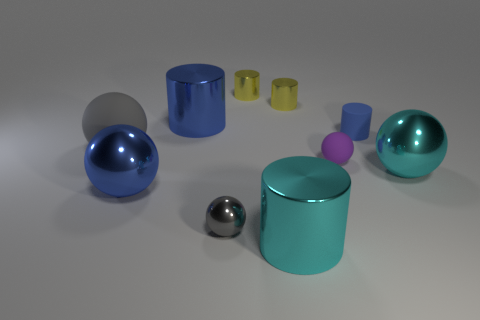The large cylinder that is to the left of the cylinder in front of the large rubber ball is what color?
Give a very brief answer. Blue. What material is the big object that is the same color as the small metal sphere?
Your answer should be compact. Rubber. There is a tiny cylinder that is to the right of the small purple matte sphere; what color is it?
Ensure brevity in your answer.  Blue. Does the matte object left of the blue ball have the same size as the large blue cylinder?
Offer a very short reply. Yes. What is the size of the metal object that is the same color as the large matte sphere?
Offer a terse response. Small. Are there any brown matte balls of the same size as the cyan cylinder?
Ensure brevity in your answer.  No. There is a large metallic ball that is left of the tiny gray shiny thing; does it have the same color as the big metal cylinder on the right side of the gray metallic object?
Provide a succinct answer. No. Are there any small metal cylinders of the same color as the matte cylinder?
Give a very brief answer. No. How many other objects are the same shape as the small gray object?
Give a very brief answer. 4. There is a matte thing that is behind the big gray matte object; what shape is it?
Your answer should be very brief. Cylinder. 